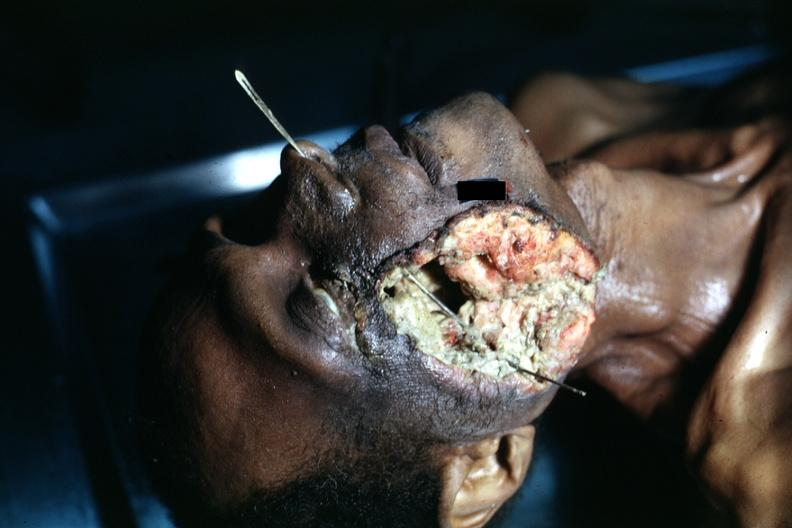s inflamed exocervix grew to outside?
Answer the question using a single word or phrase. No 